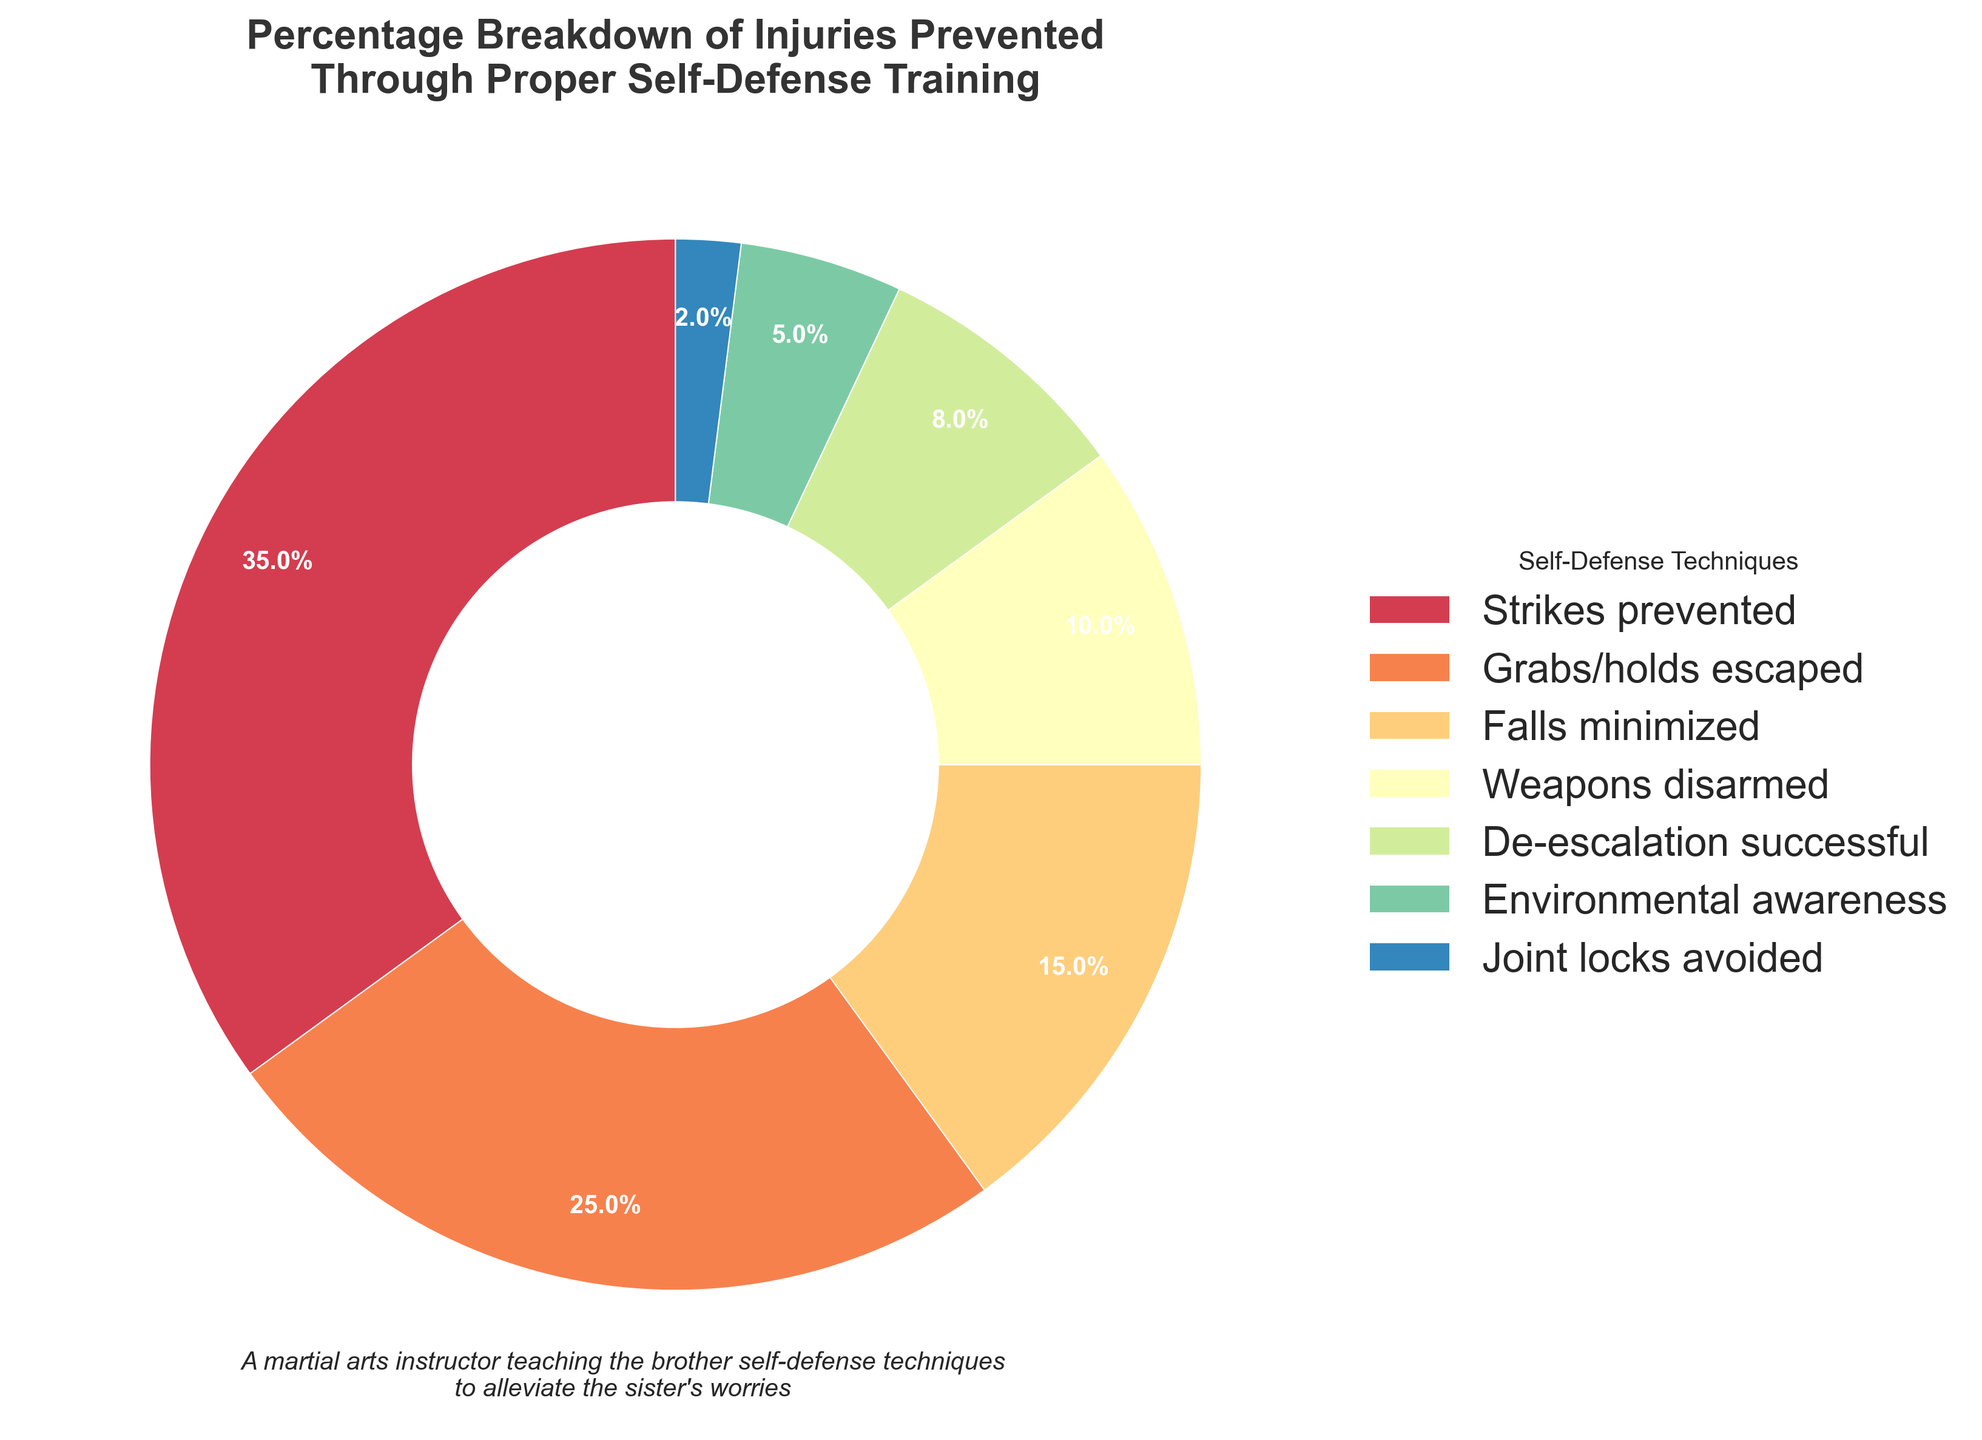What percentage of injuries are prevented by de-escalation techniques? To find the percentage of injuries prevented by de-escalation techniques, you locate the corresponding segment on the pie chart and read the percentage label directly. The label for de-escalation techniques shows 8%.
Answer: 8% Which category contributes the most to injury prevention? To find the category that contributes the most to injury prevention, compare the percentage values of each category portrayed in the pie chart. The largest segment represents strikes prevented, which is 35%.
Answer: Strikes prevented Which categories together account for more than 50% of injury prevention? To determine which categories together account for more than 50%, sum the percentages from the highest down until the total exceeds 50%. Start with strikes prevented (35%), then add grabs/holds escaped (25%). The total is 35% + 25% = 60%, which exceeds 50%.
Answer: Strikes prevented, Grabs/holds escaped How does the percentage of falls minimized compare to that of joint locks avoided? To compare these two categories, look at their percentages on the pie chart. Falls minimized is 15%, and joint locks avoided is 2%. 15% is greater than 2%.
Answer: Falls minimized is greater What is the combined percentage of falls minimized, weapons disarmed, and environmental awareness? Sum the percentages of the corresponding categories: falls minimized (15%), weapons disarmed (10%), and environmental awareness (5%). The sum is 15% + 10% + 5% = 30%.
Answer: 30% Which category has the smallest contribution to injury prevention? Identify the segment with the smallest percentage in the pie chart. Joint locks avoided has the smallest contribution with 2%.
Answer: Joint locks avoided What is the difference in percentage between grabs/holds escaped and de-escalation successful? Subtract the percentage of de-escalation successful (8%) from the percentage of grabs/holds escaped (25%). The difference is 25% - 8% = 17%.
Answer: 17% How do the contributions of weapons disarmed and environmental awareness compare in terms of percentage? To compare the contributions, examine their respective percentages in the chart. Weapons disarmed is at 10%, and environmental awareness is at 5%. 10% is greater than 5%.
Answer: Weapons disarmed is greater If you exclude the top three categories, what percentage of total injury prevention do the remaining categories represent? First, find the sum of the top three categories: strikes prevented (35%), grabs/holds escaped (25%), and falls minimized (15%). The sum is 35% + 25% + 15% = 75%. Subtract this from 100% to get the remaining percentage: 100% - 75% = 25%.
Answer: 25% Among the listed categories, which two categories together contribute exactly 12% of injury prevention? Look for two segments which collectively add up to 12%. Joint locks avoided is 2%, and environmental awareness is 5%. Adding another segment won't equal exactly 12%. The exact answer lies in joint locks avoided (2%) and weapons disarmed (10%): 2% + 10% = 12%.
Answer: Joint locks avoided, Weapons disarmed 